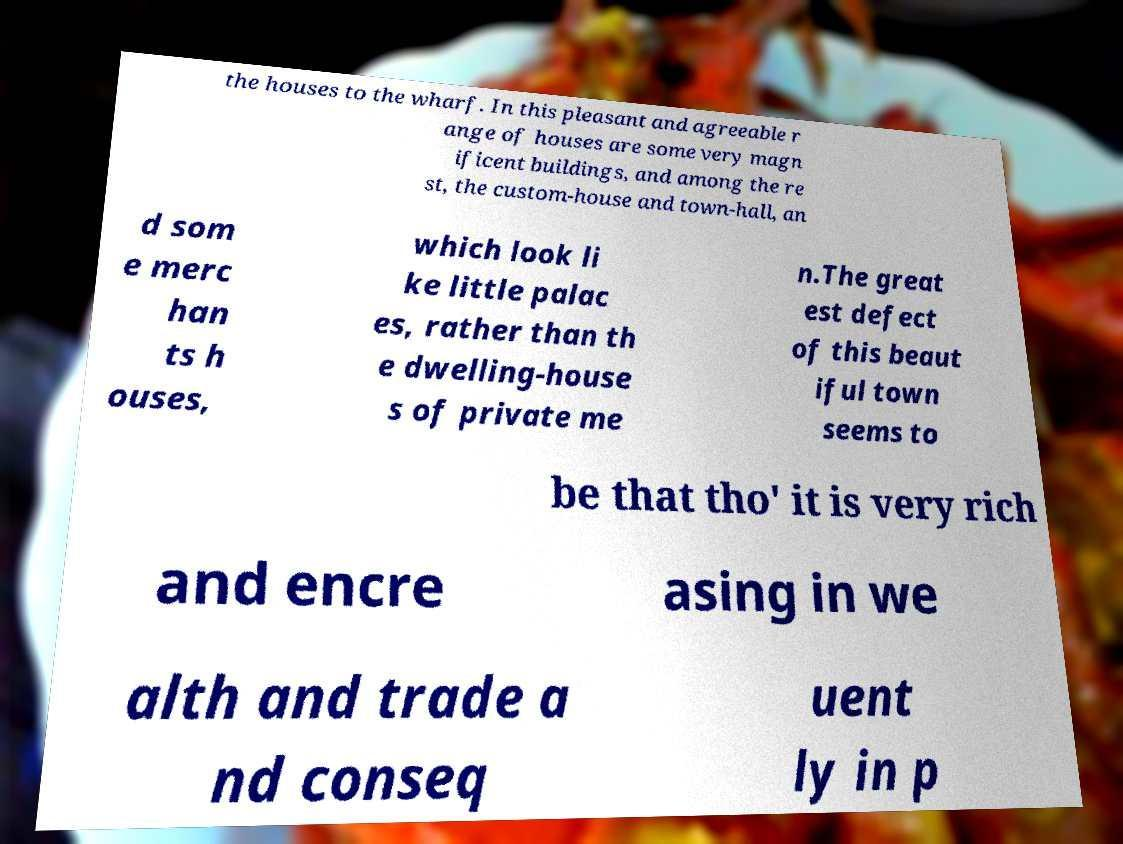Could you extract and type out the text from this image? the houses to the wharf. In this pleasant and agreeable r ange of houses are some very magn ificent buildings, and among the re st, the custom-house and town-hall, an d som e merc han ts h ouses, which look li ke little palac es, rather than th e dwelling-house s of private me n.The great est defect of this beaut iful town seems to be that tho' it is very rich and encre asing in we alth and trade a nd conseq uent ly in p 